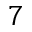<formula> <loc_0><loc_0><loc_500><loc_500>7</formula> 